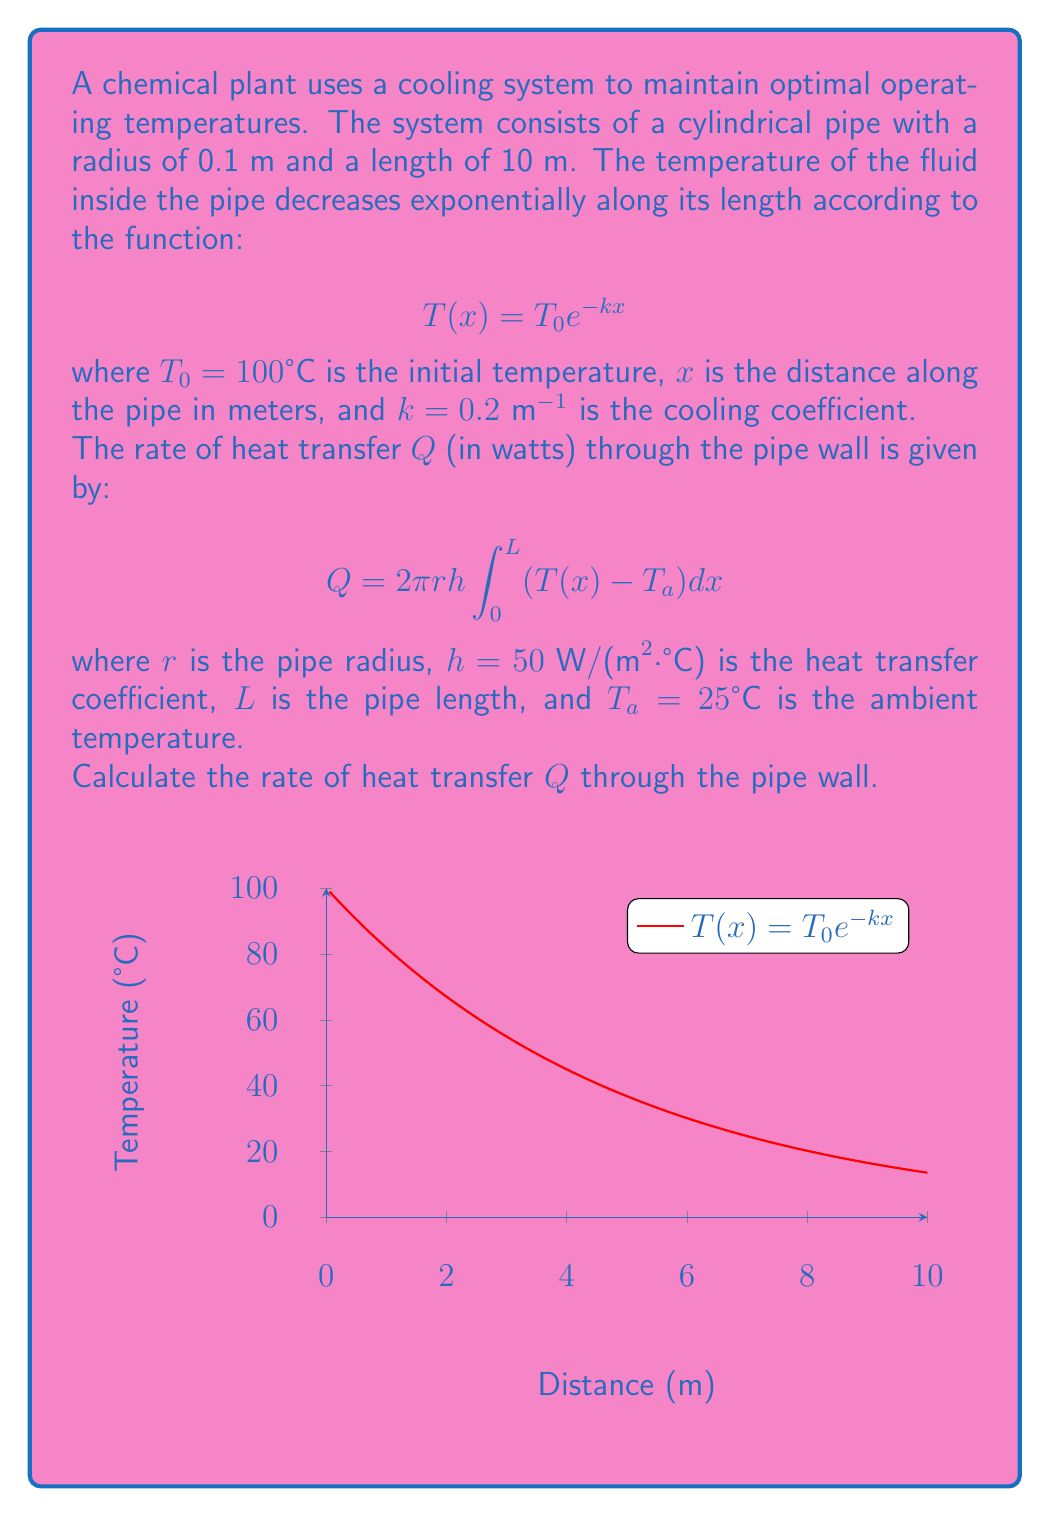Provide a solution to this math problem. Let's solve this problem step by step:

1) We are given the temperature function:
   $$T(x) = T_0 e^{-kx} = 100 e^{-0.2x}$$

2) The rate of heat transfer is given by:
   $$Q = 2\pi r h \int_0^L (T(x) - T_a) dx$$

3) Let's substitute the known values:
   $$Q = 2\pi (0.1 \text{ m}) (50 \text{ W/(m²·°C)}) \int_0^{10} (100 e^{-0.2x} - 25) dx$$

4) Simplify the constant terms:
   $$Q = 10\pi \int_0^{10} (100 e^{-0.2x} - 25) dx$$

5) Now, let's evaluate the integral:
   $$Q = 10\pi \left[ -500 e^{-0.2x} - 25x \right]_0^{10}$$

6) Evaluate the definite integral:
   $$Q = 10\pi \left[ (-500 e^{-2} - 250) - (-500 - 0) \right]$$

7) Simplify:
   $$Q = 10\pi (500 - 500 e^{-2} - 250)$$
   $$Q = 10\pi (250 - 500 e^{-2})$$

8) Calculate the final result:
   $$Q \approx 2356.19 \text{ W}$$
Answer: $2356.19$ W 